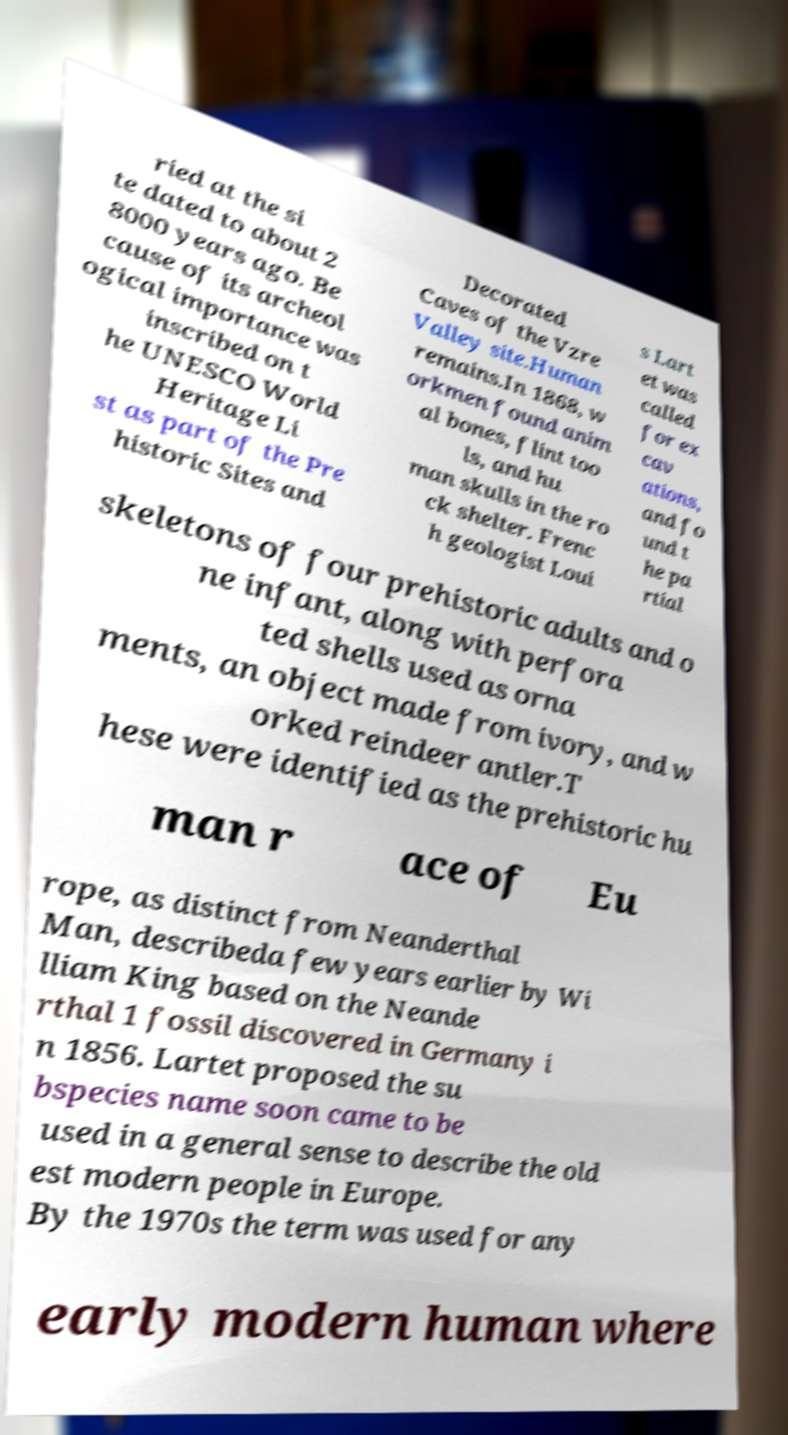Please read and relay the text visible in this image. What does it say? ried at the si te dated to about 2 8000 years ago. Be cause of its archeol ogical importance was inscribed on t he UNESCO World Heritage Li st as part of the Pre historic Sites and Decorated Caves of the Vzre Valley site.Human remains.In 1868, w orkmen found anim al bones, flint too ls, and hu man skulls in the ro ck shelter. Frenc h geologist Loui s Lart et was called for ex cav ations, and fo und t he pa rtial skeletons of four prehistoric adults and o ne infant, along with perfora ted shells used as orna ments, an object made from ivory, and w orked reindeer antler.T hese were identified as the prehistoric hu man r ace of Eu rope, as distinct from Neanderthal Man, describeda few years earlier by Wi lliam King based on the Neande rthal 1 fossil discovered in Germany i n 1856. Lartet proposed the su bspecies name soon came to be used in a general sense to describe the old est modern people in Europe. By the 1970s the term was used for any early modern human where 